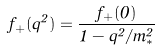Convert formula to latex. <formula><loc_0><loc_0><loc_500><loc_500>f _ { + } ( q ^ { 2 } ) = \frac { f _ { + } ( 0 ) } { 1 - q ^ { 2 } / m ^ { 2 } _ { * } }</formula> 